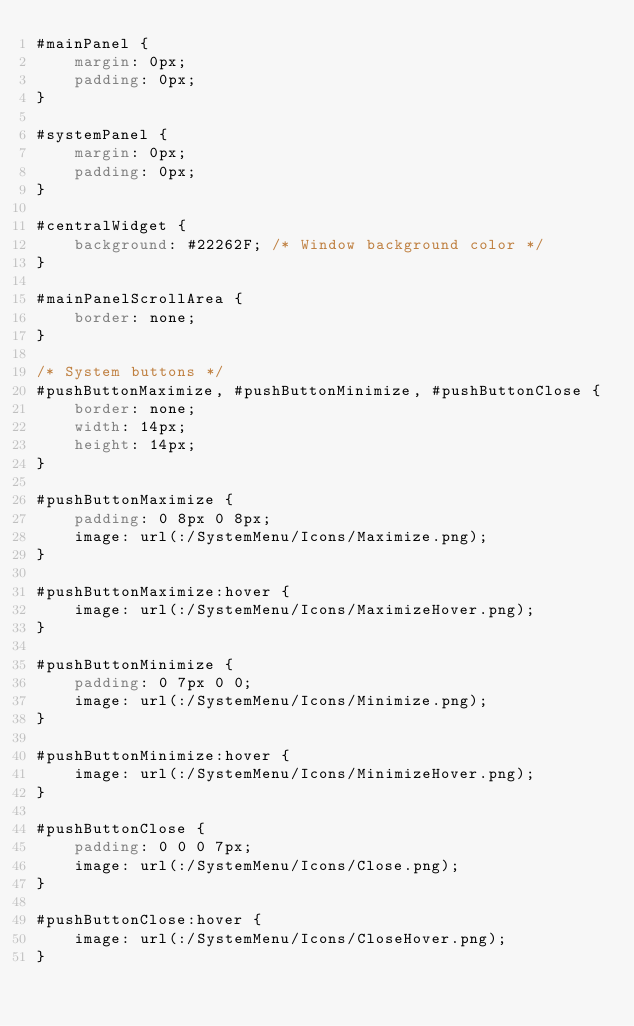<code> <loc_0><loc_0><loc_500><loc_500><_CSS_>#mainPanel {
    margin: 0px;
    padding: 0px;
}

#systemPanel {
    margin: 0px;
    padding: 0px;
}

#centralWidget {
    background: #22262F; /* Window background color */
}

#mainPanelScrollArea {
    border: none;
}

/* System buttons */
#pushButtonMaximize, #pushButtonMinimize, #pushButtonClose {
    border: none;
    width: 14px;
    height: 14px;
}

#pushButtonMaximize {
    padding: 0 8px 0 8px;
    image: url(:/SystemMenu/Icons/Maximize.png);
}

#pushButtonMaximize:hover {
    image: url(:/SystemMenu/Icons/MaximizeHover.png);
}

#pushButtonMinimize {
    padding: 0 7px 0 0;
    image: url(:/SystemMenu/Icons/Minimize.png);
}

#pushButtonMinimize:hover {
    image: url(:/SystemMenu/Icons/MinimizeHover.png);
}

#pushButtonClose {
    padding: 0 0 0 7px;
    image: url(:/SystemMenu/Icons/Close.png);
}

#pushButtonClose:hover {
    image: url(:/SystemMenu/Icons/CloseHover.png);
}
</code> 